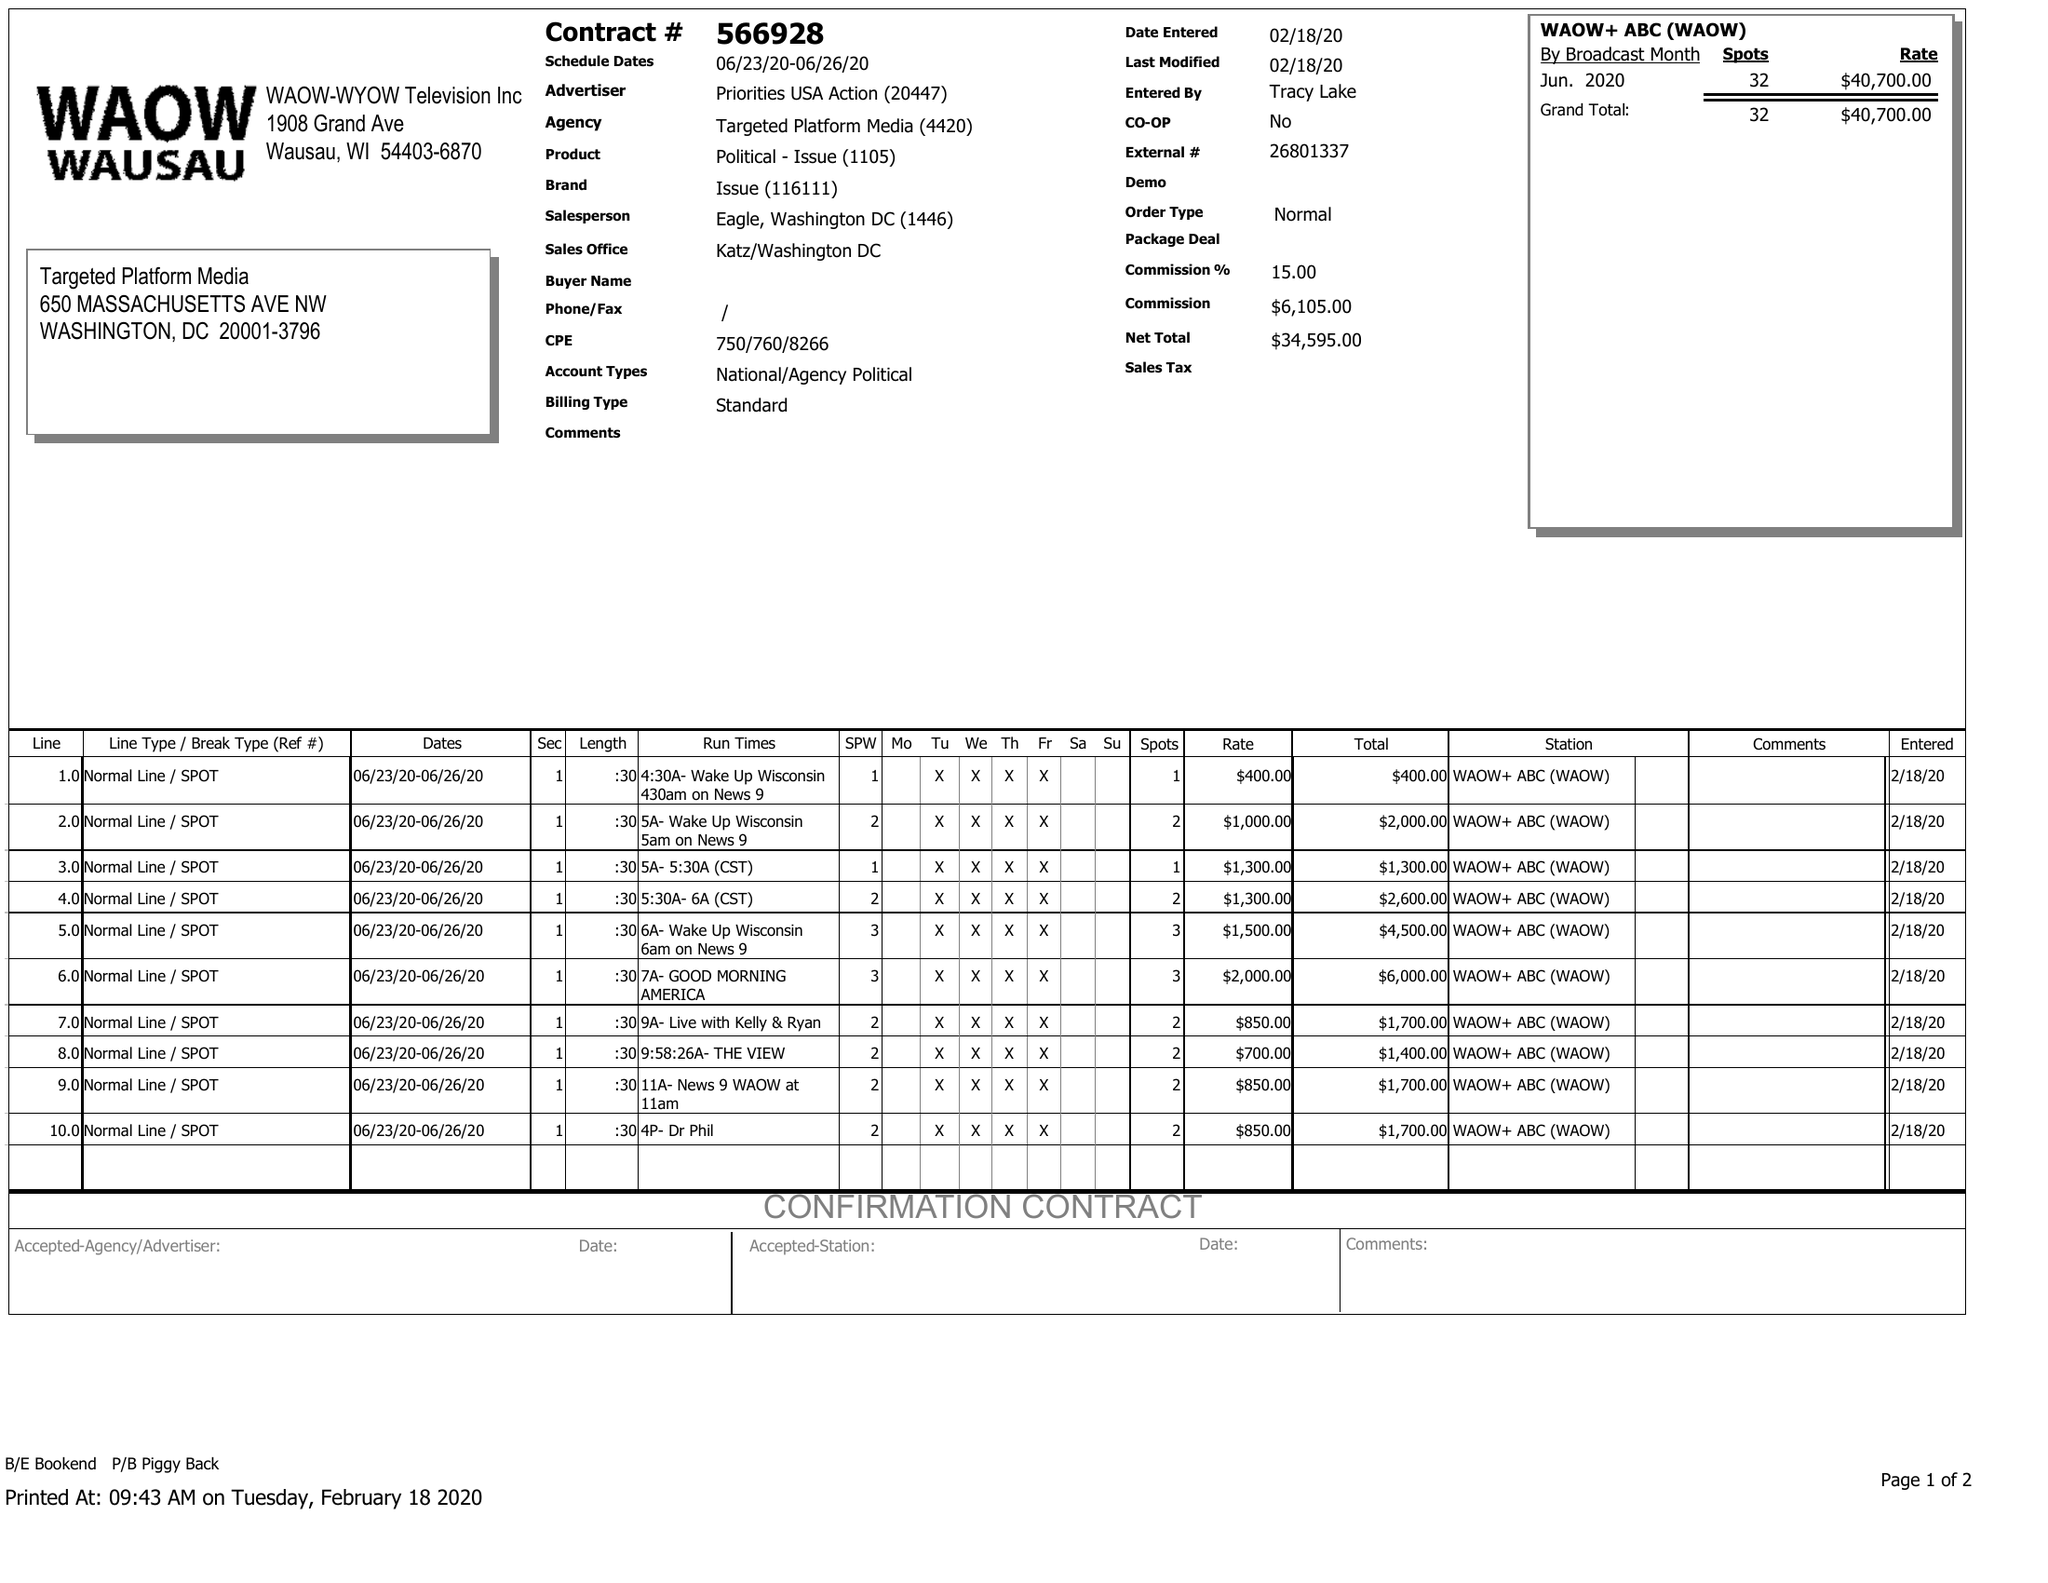What is the value for the gross_amount?
Answer the question using a single word or phrase. 40700.00 